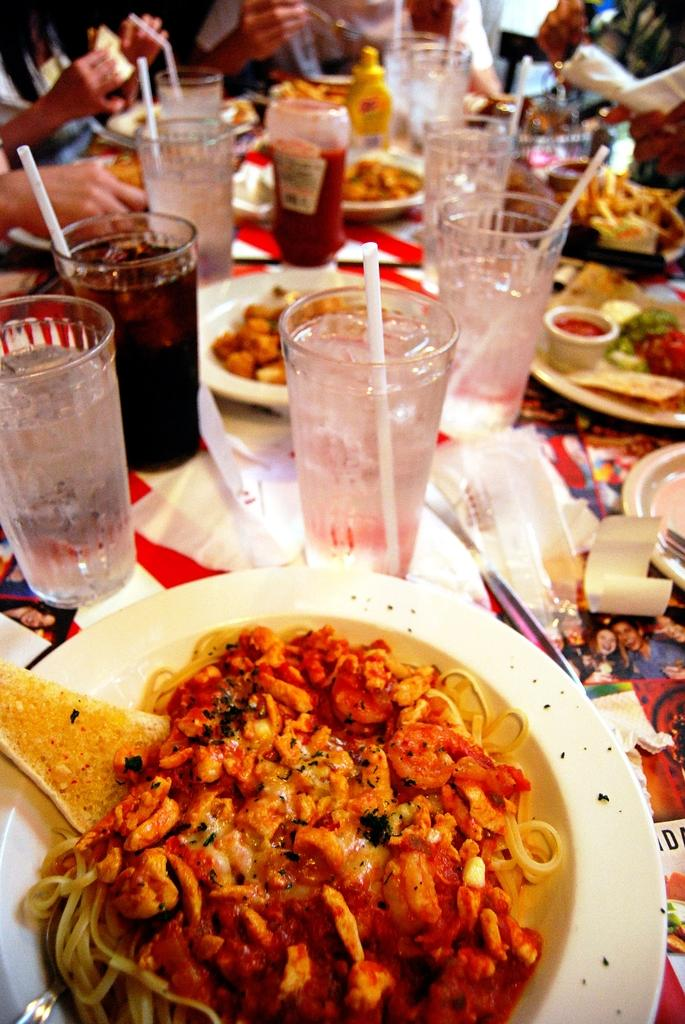What is on the plate that is visible in the image? There is a plate with food items in the image. What else can be seen on the table in the image? There are glasses on the table in the image. How many ants are crawling on the plate in the image? There are no ants visible on the plate in the image. What type of airport is shown in the background of the image? There is no airport present in the image; it only features a plate with food items and glasses on a table. 